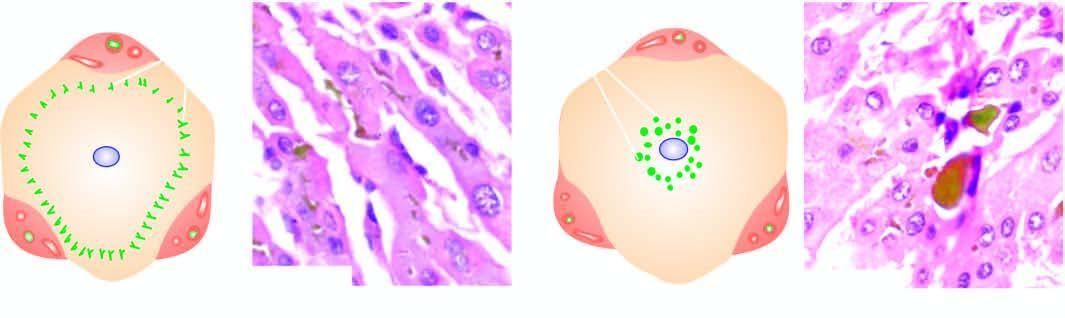does extrahepatic cholestasis show characteristic bile lakes due to rupture of canaliculi in the hepatocytes in the centrilobular area?
Answer the question using a single word or phrase. Yes 